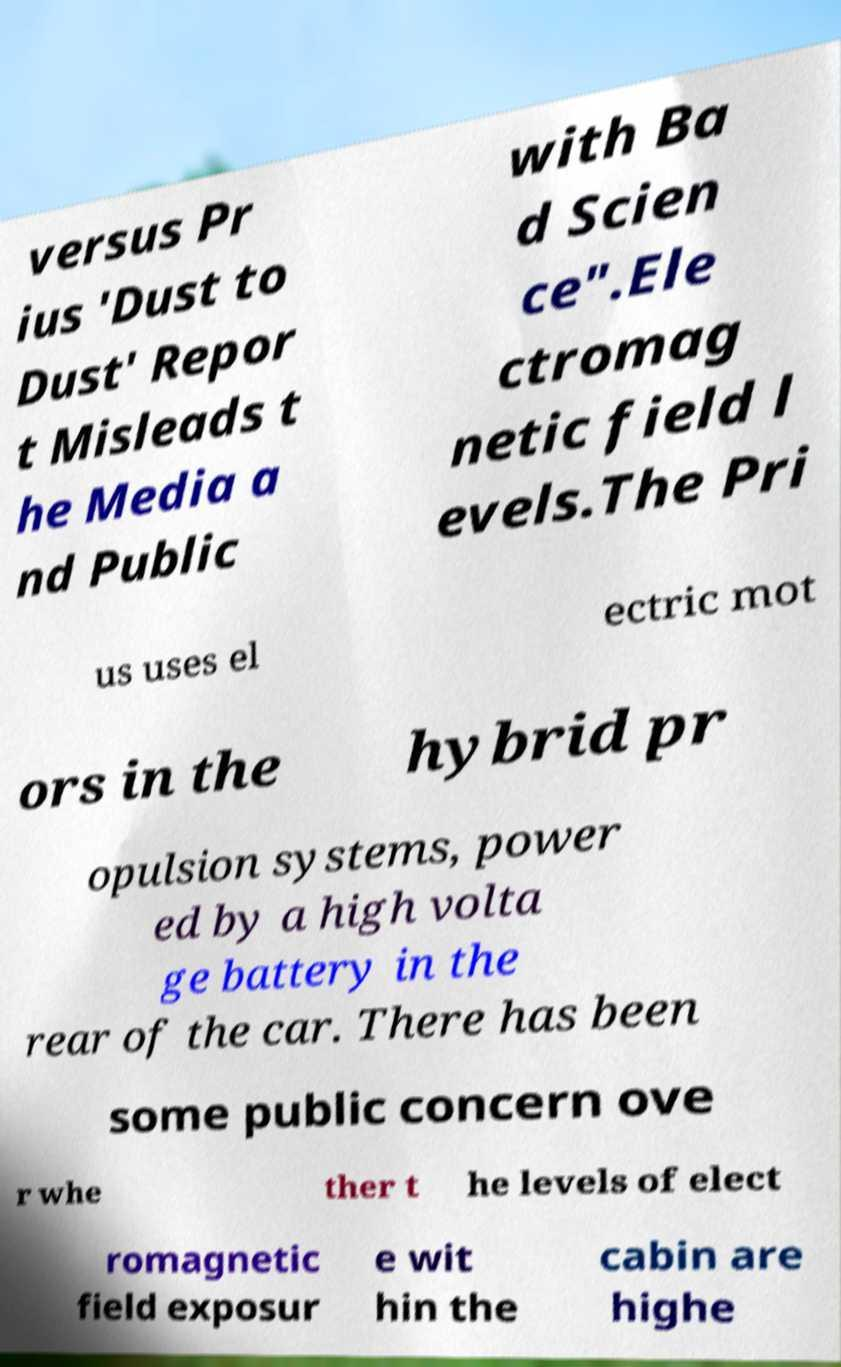There's text embedded in this image that I need extracted. Can you transcribe it verbatim? versus Pr ius 'Dust to Dust' Repor t Misleads t he Media a nd Public with Ba d Scien ce".Ele ctromag netic field l evels.The Pri us uses el ectric mot ors in the hybrid pr opulsion systems, power ed by a high volta ge battery in the rear of the car. There has been some public concern ove r whe ther t he levels of elect romagnetic field exposur e wit hin the cabin are highe 